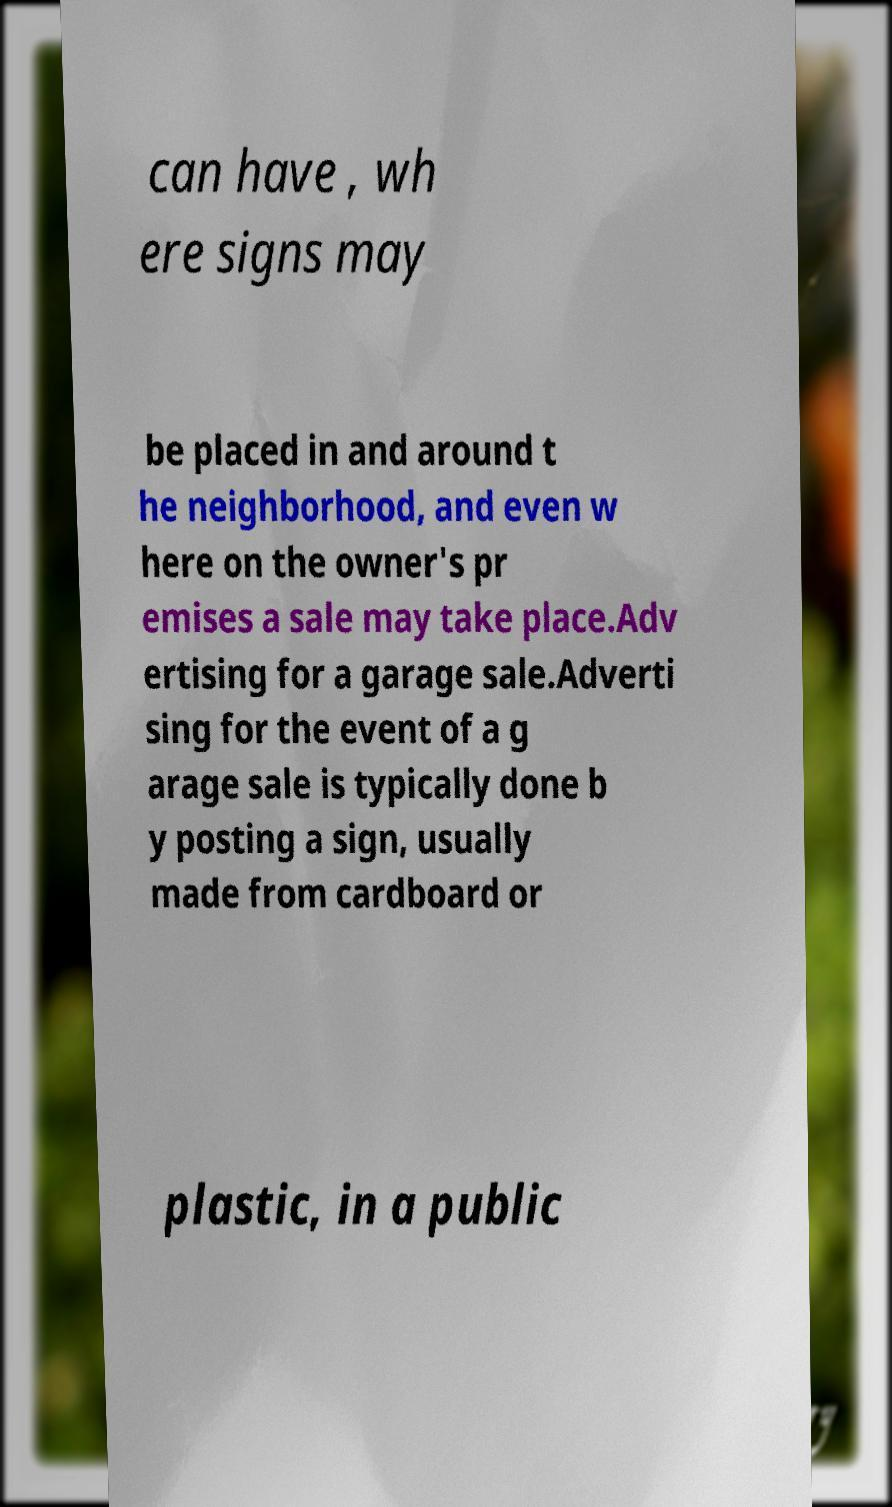What messages or text are displayed in this image? I need them in a readable, typed format. can have , wh ere signs may be placed in and around t he neighborhood, and even w here on the owner's pr emises a sale may take place.Adv ertising for a garage sale.Adverti sing for the event of a g arage sale is typically done b y posting a sign, usually made from cardboard or plastic, in a public 